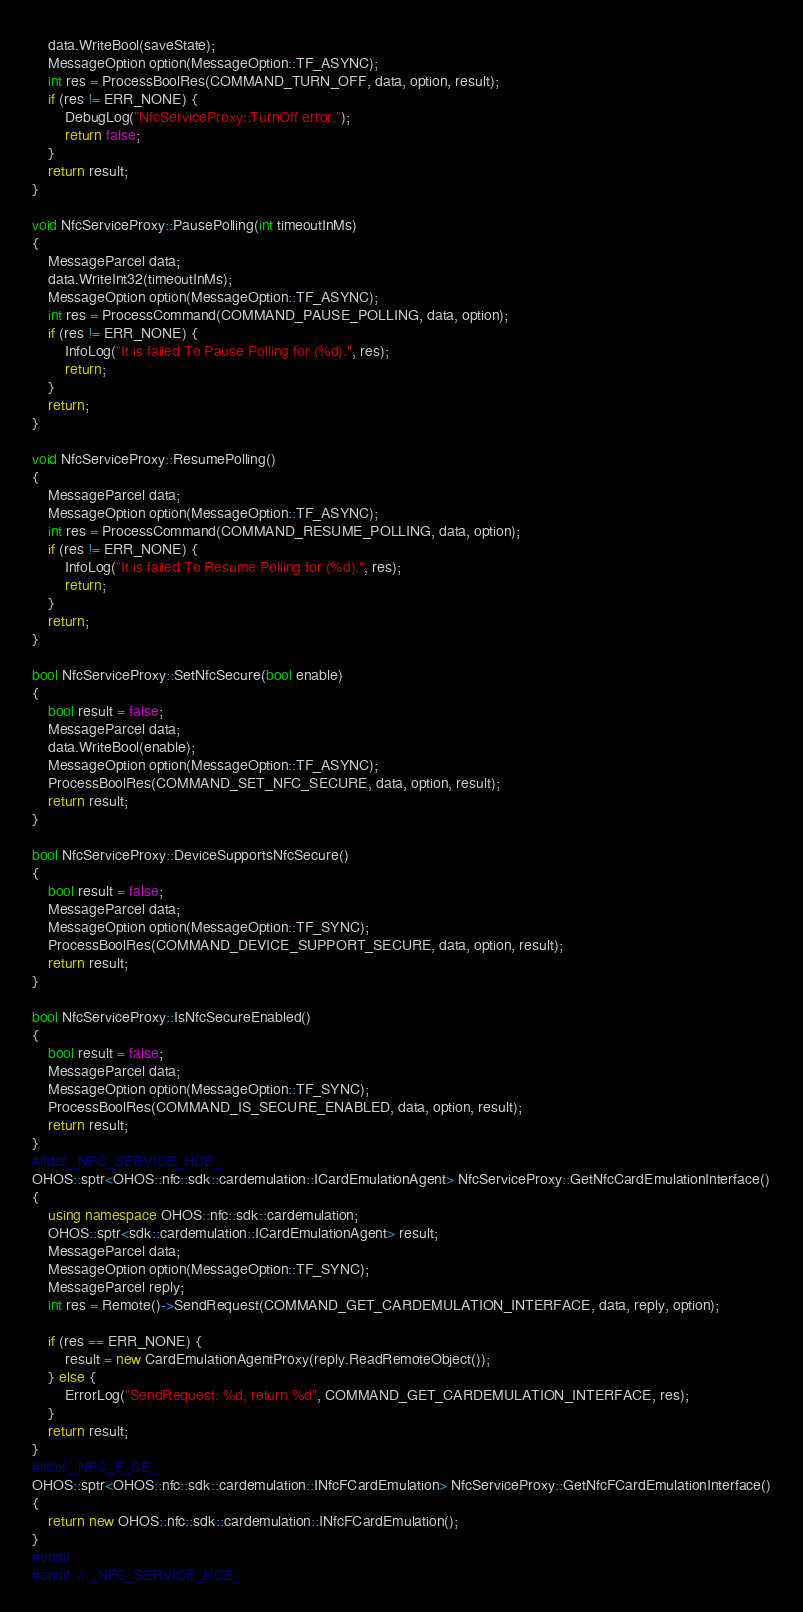<code> <loc_0><loc_0><loc_500><loc_500><_C++_>    data.WriteBool(saveState);
    MessageOption option(MessageOption::TF_ASYNC);
    int res = ProcessBoolRes(COMMAND_TURN_OFF, data, option, result);
    if (res != ERR_NONE) {
        DebugLog("NfcServiceProxy::TurnOff error.");
        return false;
    }
    return result;
}

void NfcServiceProxy::PausePolling(int timeoutInMs)
{
    MessageParcel data;
    data.WriteInt32(timeoutInMs);
    MessageOption option(MessageOption::TF_ASYNC);
    int res = ProcessCommand(COMMAND_PAUSE_POLLING, data, option);
    if (res != ERR_NONE) {
        InfoLog("It is failed To Pause Polling for (%d).", res);
        return;
    }
    return;
}

void NfcServiceProxy::ResumePolling()
{
    MessageParcel data;
    MessageOption option(MessageOption::TF_ASYNC);
    int res = ProcessCommand(COMMAND_RESUME_POLLING, data, option);
    if (res != ERR_NONE) {
        InfoLog("It is failed To Resume Polling for (%d).", res);
        return;
    }
    return;
}

bool NfcServiceProxy::SetNfcSecure(bool enable)
{
    bool result = false;
    MessageParcel data;
    data.WriteBool(enable);
    MessageOption option(MessageOption::TF_ASYNC);
    ProcessBoolRes(COMMAND_SET_NFC_SECURE, data, option, result);
    return result;
}

bool NfcServiceProxy::DeviceSupportsNfcSecure()
{
    bool result = false;
    MessageParcel data;
    MessageOption option(MessageOption::TF_SYNC);
    ProcessBoolRes(COMMAND_DEVICE_SUPPORT_SECURE, data, option, result);
    return result;
}

bool NfcServiceProxy::IsNfcSecureEnabled()
{
    bool result = false;
    MessageParcel data;
    MessageOption option(MessageOption::TF_SYNC);
    ProcessBoolRes(COMMAND_IS_SECURE_ENABLED, data, option, result);
    return result;
}
#ifdef _NFC_SERVICE_HCE_
OHOS::sptr<OHOS::nfc::sdk::cardemulation::ICardEmulationAgent> NfcServiceProxy::GetNfcCardEmulationInterface()
{
    using namespace OHOS::nfc::sdk::cardemulation;
    OHOS::sptr<sdk::cardemulation::ICardEmulationAgent> result;
    MessageParcel data;
    MessageOption option(MessageOption::TF_SYNC);
    MessageParcel reply;
    int res = Remote()->SendRequest(COMMAND_GET_CARDEMULATION_INTERFACE, data, reply, option);

    if (res == ERR_NONE) {
        result = new CardEmulationAgentProxy(reply.ReadRemoteObject());
    } else {
        ErrorLog("SendRequest: %d, return %d", COMMAND_GET_CARDEMULATION_INTERFACE, res);
    }
    return result;
}
#ifdef _NFC_F_CE_
OHOS::sptr<OHOS::nfc::sdk::cardemulation::INfcFCardEmulation> NfcServiceProxy::GetNfcFCardEmulationInterface()
{
    return new OHOS::nfc::sdk::cardemulation::INfcFCardEmulation();
}
#endif
#endif  // _NFC_SERVICE_HCE_</code> 